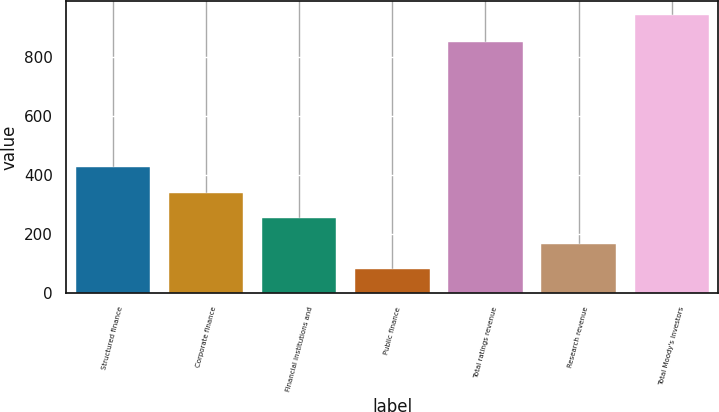Convert chart. <chart><loc_0><loc_0><loc_500><loc_500><bar_chart><fcel>Structured finance<fcel>Corporate finance<fcel>Financial institutions and<fcel>Public finance<fcel>Total ratings revenue<fcel>Research revenue<fcel>Total Moody's Investors<nl><fcel>425.44<fcel>339.38<fcel>253.32<fcel>81.2<fcel>848.2<fcel>167.26<fcel>941.8<nl></chart> 